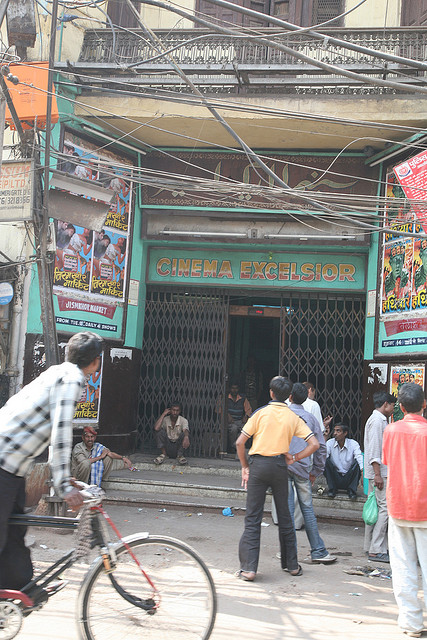Describe the condition of the building where the cinema is located. The building housing 'CINEMA EXCELSIOR' appears to be quite old, with signs of wear and tear visible on its exterior. The walls are faded and covered with numerous colorful posters, suggesting a high volume of advertising over time. The structure has a rustic charm, with a metal grill gate indicating security measures typical of older establishments. Overall, it seems to hold historical significance and has likely been a fixture in the community for many years. 